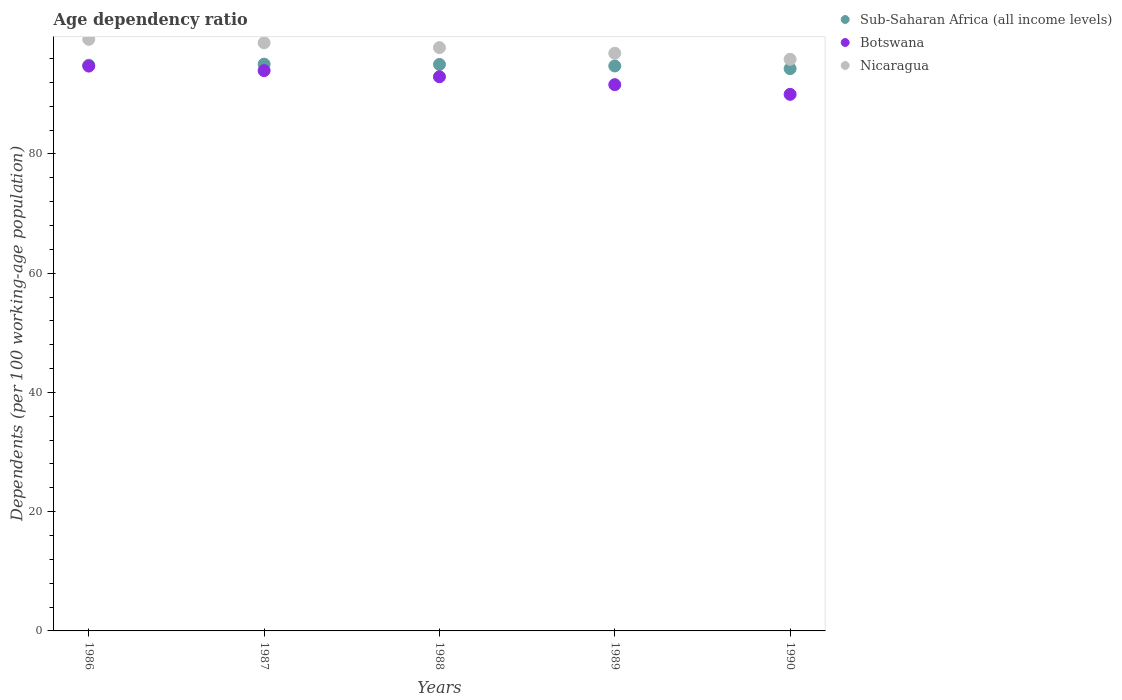How many different coloured dotlines are there?
Ensure brevity in your answer.  3. Is the number of dotlines equal to the number of legend labels?
Your answer should be compact. Yes. What is the age dependency ratio in in Nicaragua in 1988?
Ensure brevity in your answer.  97.83. Across all years, what is the maximum age dependency ratio in in Nicaragua?
Make the answer very short. 99.23. Across all years, what is the minimum age dependency ratio in in Nicaragua?
Offer a very short reply. 95.87. In which year was the age dependency ratio in in Nicaragua minimum?
Your answer should be very brief. 1990. What is the total age dependency ratio in in Sub-Saharan Africa (all income levels) in the graph?
Provide a succinct answer. 474.03. What is the difference between the age dependency ratio in in Sub-Saharan Africa (all income levels) in 1986 and that in 1989?
Your answer should be compact. 0.12. What is the difference between the age dependency ratio in in Botswana in 1988 and the age dependency ratio in in Sub-Saharan Africa (all income levels) in 1987?
Offer a very short reply. -2.11. What is the average age dependency ratio in in Nicaragua per year?
Give a very brief answer. 97.69. In the year 1986, what is the difference between the age dependency ratio in in Nicaragua and age dependency ratio in in Botswana?
Give a very brief answer. 4.49. What is the ratio of the age dependency ratio in in Botswana in 1988 to that in 1989?
Ensure brevity in your answer.  1.01. Is the age dependency ratio in in Nicaragua in 1988 less than that in 1990?
Your answer should be very brief. No. What is the difference between the highest and the second highest age dependency ratio in in Sub-Saharan Africa (all income levels)?
Give a very brief answer. 0.05. What is the difference between the highest and the lowest age dependency ratio in in Sub-Saharan Africa (all income levels)?
Your response must be concise. 0.75. Is the sum of the age dependency ratio in in Sub-Saharan Africa (all income levels) in 1986 and 1987 greater than the maximum age dependency ratio in in Nicaragua across all years?
Your response must be concise. Yes. Is it the case that in every year, the sum of the age dependency ratio in in Sub-Saharan Africa (all income levels) and age dependency ratio in in Botswana  is greater than the age dependency ratio in in Nicaragua?
Offer a terse response. Yes. Does the age dependency ratio in in Botswana monotonically increase over the years?
Your answer should be compact. No. Is the age dependency ratio in in Botswana strictly greater than the age dependency ratio in in Nicaragua over the years?
Offer a terse response. No. Is the age dependency ratio in in Botswana strictly less than the age dependency ratio in in Nicaragua over the years?
Give a very brief answer. Yes. How many dotlines are there?
Offer a terse response. 3. How many years are there in the graph?
Offer a very short reply. 5. What is the difference between two consecutive major ticks on the Y-axis?
Ensure brevity in your answer.  20. Does the graph contain any zero values?
Provide a succinct answer. No. How are the legend labels stacked?
Keep it short and to the point. Vertical. What is the title of the graph?
Provide a short and direct response. Age dependency ratio. Does "Malawi" appear as one of the legend labels in the graph?
Keep it short and to the point. No. What is the label or title of the Y-axis?
Offer a very short reply. Dependents (per 100 working-age population). What is the Dependents (per 100 working-age population) of Sub-Saharan Africa (all income levels) in 1986?
Provide a succinct answer. 94.88. What is the Dependents (per 100 working-age population) in Botswana in 1986?
Your answer should be compact. 94.74. What is the Dependents (per 100 working-age population) of Nicaragua in 1986?
Offer a very short reply. 99.23. What is the Dependents (per 100 working-age population) of Sub-Saharan Africa (all income levels) in 1987?
Provide a short and direct response. 95.06. What is the Dependents (per 100 working-age population) of Botswana in 1987?
Your answer should be compact. 93.98. What is the Dependents (per 100 working-age population) in Nicaragua in 1987?
Provide a short and direct response. 98.65. What is the Dependents (per 100 working-age population) in Sub-Saharan Africa (all income levels) in 1988?
Offer a terse response. 95.02. What is the Dependents (per 100 working-age population) in Botswana in 1988?
Make the answer very short. 92.95. What is the Dependents (per 100 working-age population) of Nicaragua in 1988?
Keep it short and to the point. 97.83. What is the Dependents (per 100 working-age population) in Sub-Saharan Africa (all income levels) in 1989?
Keep it short and to the point. 94.76. What is the Dependents (per 100 working-age population) of Botswana in 1989?
Keep it short and to the point. 91.62. What is the Dependents (per 100 working-age population) of Nicaragua in 1989?
Your response must be concise. 96.89. What is the Dependents (per 100 working-age population) in Sub-Saharan Africa (all income levels) in 1990?
Offer a terse response. 94.31. What is the Dependents (per 100 working-age population) of Botswana in 1990?
Offer a very short reply. 90. What is the Dependents (per 100 working-age population) in Nicaragua in 1990?
Offer a terse response. 95.87. Across all years, what is the maximum Dependents (per 100 working-age population) in Sub-Saharan Africa (all income levels)?
Give a very brief answer. 95.06. Across all years, what is the maximum Dependents (per 100 working-age population) of Botswana?
Your answer should be very brief. 94.74. Across all years, what is the maximum Dependents (per 100 working-age population) of Nicaragua?
Provide a succinct answer. 99.23. Across all years, what is the minimum Dependents (per 100 working-age population) of Sub-Saharan Africa (all income levels)?
Provide a succinct answer. 94.31. Across all years, what is the minimum Dependents (per 100 working-age population) in Botswana?
Your response must be concise. 90. Across all years, what is the minimum Dependents (per 100 working-age population) in Nicaragua?
Ensure brevity in your answer.  95.87. What is the total Dependents (per 100 working-age population) in Sub-Saharan Africa (all income levels) in the graph?
Ensure brevity in your answer.  474.03. What is the total Dependents (per 100 working-age population) of Botswana in the graph?
Your answer should be very brief. 463.28. What is the total Dependents (per 100 working-age population) of Nicaragua in the graph?
Give a very brief answer. 488.47. What is the difference between the Dependents (per 100 working-age population) in Sub-Saharan Africa (all income levels) in 1986 and that in 1987?
Your response must be concise. -0.18. What is the difference between the Dependents (per 100 working-age population) in Botswana in 1986 and that in 1987?
Provide a succinct answer. 0.76. What is the difference between the Dependents (per 100 working-age population) of Nicaragua in 1986 and that in 1987?
Provide a succinct answer. 0.58. What is the difference between the Dependents (per 100 working-age population) of Sub-Saharan Africa (all income levels) in 1986 and that in 1988?
Offer a very short reply. -0.13. What is the difference between the Dependents (per 100 working-age population) in Botswana in 1986 and that in 1988?
Your answer should be very brief. 1.79. What is the difference between the Dependents (per 100 working-age population) in Nicaragua in 1986 and that in 1988?
Give a very brief answer. 1.4. What is the difference between the Dependents (per 100 working-age population) in Sub-Saharan Africa (all income levels) in 1986 and that in 1989?
Ensure brevity in your answer.  0.12. What is the difference between the Dependents (per 100 working-age population) in Botswana in 1986 and that in 1989?
Provide a succinct answer. 3.12. What is the difference between the Dependents (per 100 working-age population) of Nicaragua in 1986 and that in 1989?
Ensure brevity in your answer.  2.33. What is the difference between the Dependents (per 100 working-age population) of Sub-Saharan Africa (all income levels) in 1986 and that in 1990?
Offer a very short reply. 0.57. What is the difference between the Dependents (per 100 working-age population) in Botswana in 1986 and that in 1990?
Your answer should be very brief. 4.74. What is the difference between the Dependents (per 100 working-age population) in Nicaragua in 1986 and that in 1990?
Provide a short and direct response. 3.35. What is the difference between the Dependents (per 100 working-age population) of Sub-Saharan Africa (all income levels) in 1987 and that in 1988?
Provide a succinct answer. 0.05. What is the difference between the Dependents (per 100 working-age population) of Botswana in 1987 and that in 1988?
Ensure brevity in your answer.  1.03. What is the difference between the Dependents (per 100 working-age population) in Nicaragua in 1987 and that in 1988?
Provide a short and direct response. 0.81. What is the difference between the Dependents (per 100 working-age population) in Sub-Saharan Africa (all income levels) in 1987 and that in 1989?
Give a very brief answer. 0.3. What is the difference between the Dependents (per 100 working-age population) of Botswana in 1987 and that in 1989?
Your response must be concise. 2.36. What is the difference between the Dependents (per 100 working-age population) in Nicaragua in 1987 and that in 1989?
Provide a short and direct response. 1.75. What is the difference between the Dependents (per 100 working-age population) of Sub-Saharan Africa (all income levels) in 1987 and that in 1990?
Give a very brief answer. 0.75. What is the difference between the Dependents (per 100 working-age population) of Botswana in 1987 and that in 1990?
Your response must be concise. 3.98. What is the difference between the Dependents (per 100 working-age population) in Nicaragua in 1987 and that in 1990?
Your response must be concise. 2.77. What is the difference between the Dependents (per 100 working-age population) of Sub-Saharan Africa (all income levels) in 1988 and that in 1989?
Give a very brief answer. 0.25. What is the difference between the Dependents (per 100 working-age population) in Botswana in 1988 and that in 1989?
Offer a very short reply. 1.33. What is the difference between the Dependents (per 100 working-age population) in Nicaragua in 1988 and that in 1989?
Offer a very short reply. 0.94. What is the difference between the Dependents (per 100 working-age population) in Sub-Saharan Africa (all income levels) in 1988 and that in 1990?
Offer a terse response. 0.7. What is the difference between the Dependents (per 100 working-age population) of Botswana in 1988 and that in 1990?
Keep it short and to the point. 2.95. What is the difference between the Dependents (per 100 working-age population) of Nicaragua in 1988 and that in 1990?
Your answer should be compact. 1.96. What is the difference between the Dependents (per 100 working-age population) of Sub-Saharan Africa (all income levels) in 1989 and that in 1990?
Offer a terse response. 0.45. What is the difference between the Dependents (per 100 working-age population) of Botswana in 1989 and that in 1990?
Ensure brevity in your answer.  1.62. What is the difference between the Dependents (per 100 working-age population) of Nicaragua in 1989 and that in 1990?
Your answer should be compact. 1.02. What is the difference between the Dependents (per 100 working-age population) in Sub-Saharan Africa (all income levels) in 1986 and the Dependents (per 100 working-age population) in Botswana in 1987?
Your answer should be compact. 0.9. What is the difference between the Dependents (per 100 working-age population) in Sub-Saharan Africa (all income levels) in 1986 and the Dependents (per 100 working-age population) in Nicaragua in 1987?
Your answer should be compact. -3.76. What is the difference between the Dependents (per 100 working-age population) of Botswana in 1986 and the Dependents (per 100 working-age population) of Nicaragua in 1987?
Keep it short and to the point. -3.91. What is the difference between the Dependents (per 100 working-age population) in Sub-Saharan Africa (all income levels) in 1986 and the Dependents (per 100 working-age population) in Botswana in 1988?
Your response must be concise. 1.93. What is the difference between the Dependents (per 100 working-age population) in Sub-Saharan Africa (all income levels) in 1986 and the Dependents (per 100 working-age population) in Nicaragua in 1988?
Your answer should be very brief. -2.95. What is the difference between the Dependents (per 100 working-age population) in Botswana in 1986 and the Dependents (per 100 working-age population) in Nicaragua in 1988?
Offer a terse response. -3.09. What is the difference between the Dependents (per 100 working-age population) of Sub-Saharan Africa (all income levels) in 1986 and the Dependents (per 100 working-age population) of Botswana in 1989?
Give a very brief answer. 3.26. What is the difference between the Dependents (per 100 working-age population) in Sub-Saharan Africa (all income levels) in 1986 and the Dependents (per 100 working-age population) in Nicaragua in 1989?
Offer a very short reply. -2.01. What is the difference between the Dependents (per 100 working-age population) in Botswana in 1986 and the Dependents (per 100 working-age population) in Nicaragua in 1989?
Provide a short and direct response. -2.15. What is the difference between the Dependents (per 100 working-age population) of Sub-Saharan Africa (all income levels) in 1986 and the Dependents (per 100 working-age population) of Botswana in 1990?
Give a very brief answer. 4.89. What is the difference between the Dependents (per 100 working-age population) of Sub-Saharan Africa (all income levels) in 1986 and the Dependents (per 100 working-age population) of Nicaragua in 1990?
Give a very brief answer. -0.99. What is the difference between the Dependents (per 100 working-age population) of Botswana in 1986 and the Dependents (per 100 working-age population) of Nicaragua in 1990?
Offer a very short reply. -1.13. What is the difference between the Dependents (per 100 working-age population) in Sub-Saharan Africa (all income levels) in 1987 and the Dependents (per 100 working-age population) in Botswana in 1988?
Your response must be concise. 2.11. What is the difference between the Dependents (per 100 working-age population) in Sub-Saharan Africa (all income levels) in 1987 and the Dependents (per 100 working-age population) in Nicaragua in 1988?
Provide a short and direct response. -2.77. What is the difference between the Dependents (per 100 working-age population) of Botswana in 1987 and the Dependents (per 100 working-age population) of Nicaragua in 1988?
Ensure brevity in your answer.  -3.85. What is the difference between the Dependents (per 100 working-age population) of Sub-Saharan Africa (all income levels) in 1987 and the Dependents (per 100 working-age population) of Botswana in 1989?
Your answer should be compact. 3.44. What is the difference between the Dependents (per 100 working-age population) in Sub-Saharan Africa (all income levels) in 1987 and the Dependents (per 100 working-age population) in Nicaragua in 1989?
Make the answer very short. -1.83. What is the difference between the Dependents (per 100 working-age population) of Botswana in 1987 and the Dependents (per 100 working-age population) of Nicaragua in 1989?
Ensure brevity in your answer.  -2.91. What is the difference between the Dependents (per 100 working-age population) in Sub-Saharan Africa (all income levels) in 1987 and the Dependents (per 100 working-age population) in Botswana in 1990?
Your answer should be compact. 5.06. What is the difference between the Dependents (per 100 working-age population) of Sub-Saharan Africa (all income levels) in 1987 and the Dependents (per 100 working-age population) of Nicaragua in 1990?
Ensure brevity in your answer.  -0.81. What is the difference between the Dependents (per 100 working-age population) of Botswana in 1987 and the Dependents (per 100 working-age population) of Nicaragua in 1990?
Give a very brief answer. -1.89. What is the difference between the Dependents (per 100 working-age population) of Sub-Saharan Africa (all income levels) in 1988 and the Dependents (per 100 working-age population) of Botswana in 1989?
Your response must be concise. 3.4. What is the difference between the Dependents (per 100 working-age population) in Sub-Saharan Africa (all income levels) in 1988 and the Dependents (per 100 working-age population) in Nicaragua in 1989?
Your answer should be compact. -1.88. What is the difference between the Dependents (per 100 working-age population) in Botswana in 1988 and the Dependents (per 100 working-age population) in Nicaragua in 1989?
Your response must be concise. -3.94. What is the difference between the Dependents (per 100 working-age population) in Sub-Saharan Africa (all income levels) in 1988 and the Dependents (per 100 working-age population) in Botswana in 1990?
Keep it short and to the point. 5.02. What is the difference between the Dependents (per 100 working-age population) in Sub-Saharan Africa (all income levels) in 1988 and the Dependents (per 100 working-age population) in Nicaragua in 1990?
Make the answer very short. -0.86. What is the difference between the Dependents (per 100 working-age population) in Botswana in 1988 and the Dependents (per 100 working-age population) in Nicaragua in 1990?
Provide a short and direct response. -2.92. What is the difference between the Dependents (per 100 working-age population) in Sub-Saharan Africa (all income levels) in 1989 and the Dependents (per 100 working-age population) in Botswana in 1990?
Your answer should be compact. 4.76. What is the difference between the Dependents (per 100 working-age population) in Sub-Saharan Africa (all income levels) in 1989 and the Dependents (per 100 working-age population) in Nicaragua in 1990?
Provide a short and direct response. -1.11. What is the difference between the Dependents (per 100 working-age population) of Botswana in 1989 and the Dependents (per 100 working-age population) of Nicaragua in 1990?
Provide a succinct answer. -4.25. What is the average Dependents (per 100 working-age population) in Sub-Saharan Africa (all income levels) per year?
Your answer should be very brief. 94.81. What is the average Dependents (per 100 working-age population) in Botswana per year?
Give a very brief answer. 92.66. What is the average Dependents (per 100 working-age population) in Nicaragua per year?
Your answer should be very brief. 97.69. In the year 1986, what is the difference between the Dependents (per 100 working-age population) in Sub-Saharan Africa (all income levels) and Dependents (per 100 working-age population) in Botswana?
Offer a very short reply. 0.14. In the year 1986, what is the difference between the Dependents (per 100 working-age population) of Sub-Saharan Africa (all income levels) and Dependents (per 100 working-age population) of Nicaragua?
Give a very brief answer. -4.34. In the year 1986, what is the difference between the Dependents (per 100 working-age population) of Botswana and Dependents (per 100 working-age population) of Nicaragua?
Provide a succinct answer. -4.49. In the year 1987, what is the difference between the Dependents (per 100 working-age population) in Sub-Saharan Africa (all income levels) and Dependents (per 100 working-age population) in Botswana?
Provide a succinct answer. 1.08. In the year 1987, what is the difference between the Dependents (per 100 working-age population) of Sub-Saharan Africa (all income levels) and Dependents (per 100 working-age population) of Nicaragua?
Ensure brevity in your answer.  -3.58. In the year 1987, what is the difference between the Dependents (per 100 working-age population) in Botswana and Dependents (per 100 working-age population) in Nicaragua?
Provide a short and direct response. -4.66. In the year 1988, what is the difference between the Dependents (per 100 working-age population) of Sub-Saharan Africa (all income levels) and Dependents (per 100 working-age population) of Botswana?
Make the answer very short. 2.07. In the year 1988, what is the difference between the Dependents (per 100 working-age population) in Sub-Saharan Africa (all income levels) and Dependents (per 100 working-age population) in Nicaragua?
Your response must be concise. -2.82. In the year 1988, what is the difference between the Dependents (per 100 working-age population) in Botswana and Dependents (per 100 working-age population) in Nicaragua?
Your answer should be compact. -4.88. In the year 1989, what is the difference between the Dependents (per 100 working-age population) in Sub-Saharan Africa (all income levels) and Dependents (per 100 working-age population) in Botswana?
Provide a succinct answer. 3.14. In the year 1989, what is the difference between the Dependents (per 100 working-age population) in Sub-Saharan Africa (all income levels) and Dependents (per 100 working-age population) in Nicaragua?
Your answer should be very brief. -2.13. In the year 1989, what is the difference between the Dependents (per 100 working-age population) in Botswana and Dependents (per 100 working-age population) in Nicaragua?
Your response must be concise. -5.27. In the year 1990, what is the difference between the Dependents (per 100 working-age population) in Sub-Saharan Africa (all income levels) and Dependents (per 100 working-age population) in Botswana?
Your response must be concise. 4.31. In the year 1990, what is the difference between the Dependents (per 100 working-age population) in Sub-Saharan Africa (all income levels) and Dependents (per 100 working-age population) in Nicaragua?
Your response must be concise. -1.56. In the year 1990, what is the difference between the Dependents (per 100 working-age population) in Botswana and Dependents (per 100 working-age population) in Nicaragua?
Give a very brief answer. -5.88. What is the ratio of the Dependents (per 100 working-age population) in Sub-Saharan Africa (all income levels) in 1986 to that in 1987?
Your answer should be compact. 1. What is the ratio of the Dependents (per 100 working-age population) in Nicaragua in 1986 to that in 1987?
Make the answer very short. 1.01. What is the ratio of the Dependents (per 100 working-age population) in Botswana in 1986 to that in 1988?
Give a very brief answer. 1.02. What is the ratio of the Dependents (per 100 working-age population) in Nicaragua in 1986 to that in 1988?
Your answer should be very brief. 1.01. What is the ratio of the Dependents (per 100 working-age population) in Sub-Saharan Africa (all income levels) in 1986 to that in 1989?
Offer a very short reply. 1. What is the ratio of the Dependents (per 100 working-age population) in Botswana in 1986 to that in 1989?
Keep it short and to the point. 1.03. What is the ratio of the Dependents (per 100 working-age population) of Nicaragua in 1986 to that in 1989?
Keep it short and to the point. 1.02. What is the ratio of the Dependents (per 100 working-age population) of Sub-Saharan Africa (all income levels) in 1986 to that in 1990?
Your response must be concise. 1.01. What is the ratio of the Dependents (per 100 working-age population) of Botswana in 1986 to that in 1990?
Your answer should be compact. 1.05. What is the ratio of the Dependents (per 100 working-age population) in Nicaragua in 1986 to that in 1990?
Give a very brief answer. 1.03. What is the ratio of the Dependents (per 100 working-age population) of Sub-Saharan Africa (all income levels) in 1987 to that in 1988?
Provide a succinct answer. 1. What is the ratio of the Dependents (per 100 working-age population) of Botswana in 1987 to that in 1988?
Make the answer very short. 1.01. What is the ratio of the Dependents (per 100 working-age population) in Nicaragua in 1987 to that in 1988?
Offer a terse response. 1.01. What is the ratio of the Dependents (per 100 working-age population) of Sub-Saharan Africa (all income levels) in 1987 to that in 1989?
Keep it short and to the point. 1. What is the ratio of the Dependents (per 100 working-age population) in Botswana in 1987 to that in 1989?
Offer a very short reply. 1.03. What is the ratio of the Dependents (per 100 working-age population) of Nicaragua in 1987 to that in 1989?
Provide a succinct answer. 1.02. What is the ratio of the Dependents (per 100 working-age population) of Botswana in 1987 to that in 1990?
Make the answer very short. 1.04. What is the ratio of the Dependents (per 100 working-age population) of Nicaragua in 1987 to that in 1990?
Offer a very short reply. 1.03. What is the ratio of the Dependents (per 100 working-age population) in Sub-Saharan Africa (all income levels) in 1988 to that in 1989?
Your answer should be very brief. 1. What is the ratio of the Dependents (per 100 working-age population) of Botswana in 1988 to that in 1989?
Ensure brevity in your answer.  1.01. What is the ratio of the Dependents (per 100 working-age population) in Nicaragua in 1988 to that in 1989?
Give a very brief answer. 1.01. What is the ratio of the Dependents (per 100 working-age population) in Sub-Saharan Africa (all income levels) in 1988 to that in 1990?
Give a very brief answer. 1.01. What is the ratio of the Dependents (per 100 working-age population) of Botswana in 1988 to that in 1990?
Your answer should be compact. 1.03. What is the ratio of the Dependents (per 100 working-age population) in Nicaragua in 1988 to that in 1990?
Provide a succinct answer. 1.02. What is the ratio of the Dependents (per 100 working-age population) in Nicaragua in 1989 to that in 1990?
Your response must be concise. 1.01. What is the difference between the highest and the second highest Dependents (per 100 working-age population) of Sub-Saharan Africa (all income levels)?
Give a very brief answer. 0.05. What is the difference between the highest and the second highest Dependents (per 100 working-age population) of Botswana?
Keep it short and to the point. 0.76. What is the difference between the highest and the second highest Dependents (per 100 working-age population) of Nicaragua?
Make the answer very short. 0.58. What is the difference between the highest and the lowest Dependents (per 100 working-age population) in Sub-Saharan Africa (all income levels)?
Keep it short and to the point. 0.75. What is the difference between the highest and the lowest Dependents (per 100 working-age population) of Botswana?
Give a very brief answer. 4.74. What is the difference between the highest and the lowest Dependents (per 100 working-age population) of Nicaragua?
Give a very brief answer. 3.35. 